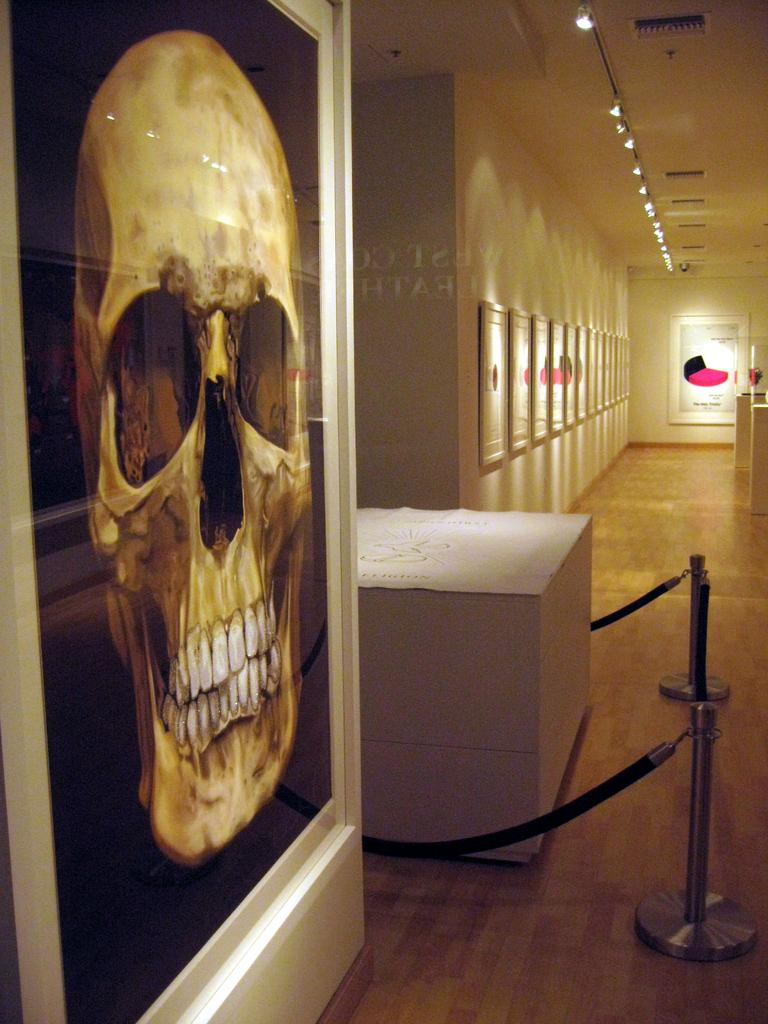What is located on the left side of the image? There is a poster on the left side of the image. What can be seen in the middle of the image? There is a board and railing in the middle of the image. What is attached to the wall in the background of the image? There are frames attached to the wall in the background of the image. What is visible at the top of the image? There is a light and a ceiling visible at the top of the image. Can you tell me how many blades are attached to the mouth of the person in the image? There is no person present in the image, and therefore no mouth or blades can be observed. What type of invention is being showcased in the image? There is no invention showcased in the image; it features a poster, a board, railing, frames, a light, and a ceiling. 